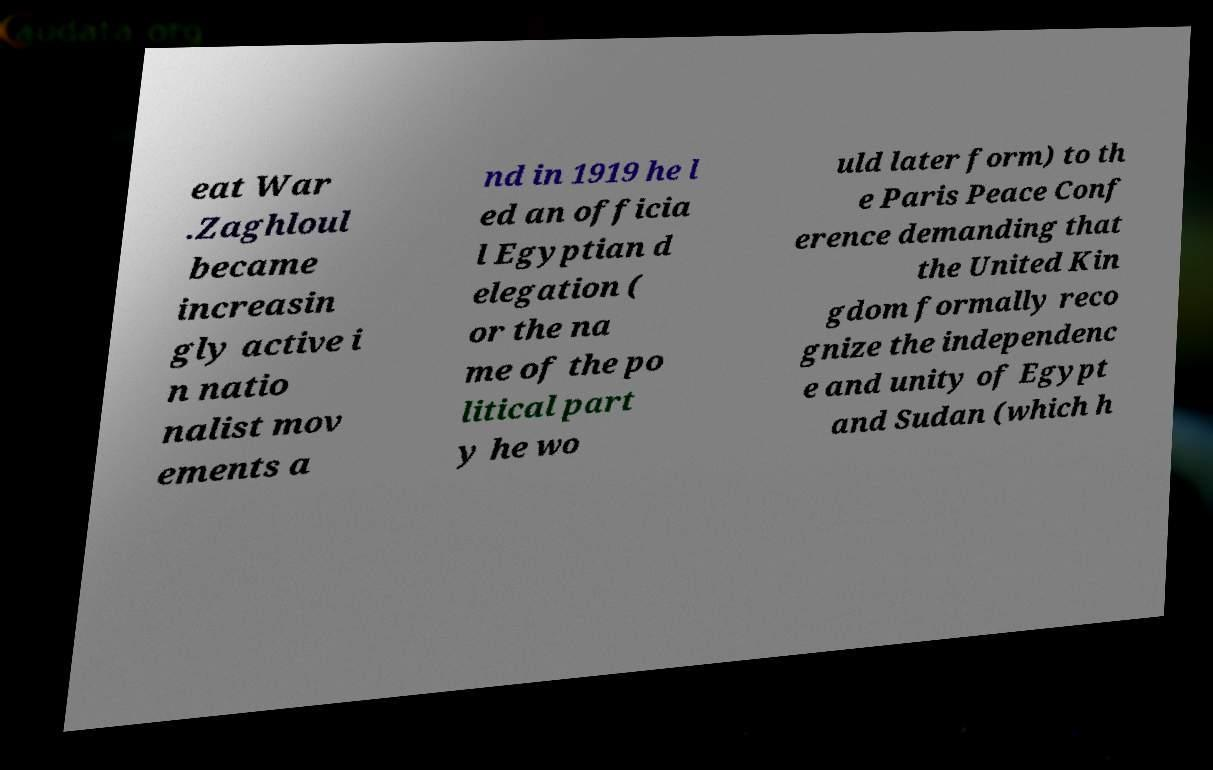There's text embedded in this image that I need extracted. Can you transcribe it verbatim? eat War .Zaghloul became increasin gly active i n natio nalist mov ements a nd in 1919 he l ed an officia l Egyptian d elegation ( or the na me of the po litical part y he wo uld later form) to th e Paris Peace Conf erence demanding that the United Kin gdom formally reco gnize the independenc e and unity of Egypt and Sudan (which h 